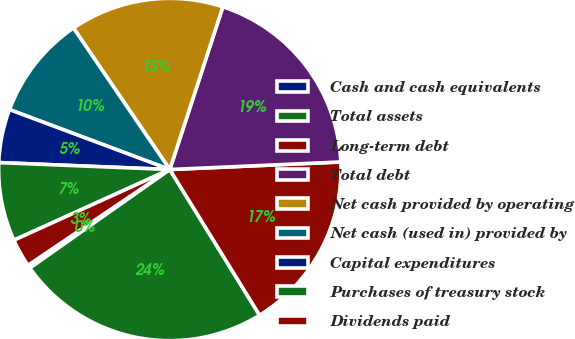<chart> <loc_0><loc_0><loc_500><loc_500><pie_chart><fcel>Cash and cash equivalents<fcel>Total assets<fcel>Long-term debt<fcel>Total debt<fcel>Net cash provided by operating<fcel>Net cash (used in) provided by<fcel>Capital expenditures<fcel>Purchases of treasury stock<fcel>Dividends paid<nl><fcel>0.31%<fcel>24.02%<fcel>16.91%<fcel>19.28%<fcel>14.53%<fcel>9.79%<fcel>5.05%<fcel>7.42%<fcel>2.68%<nl></chart> 